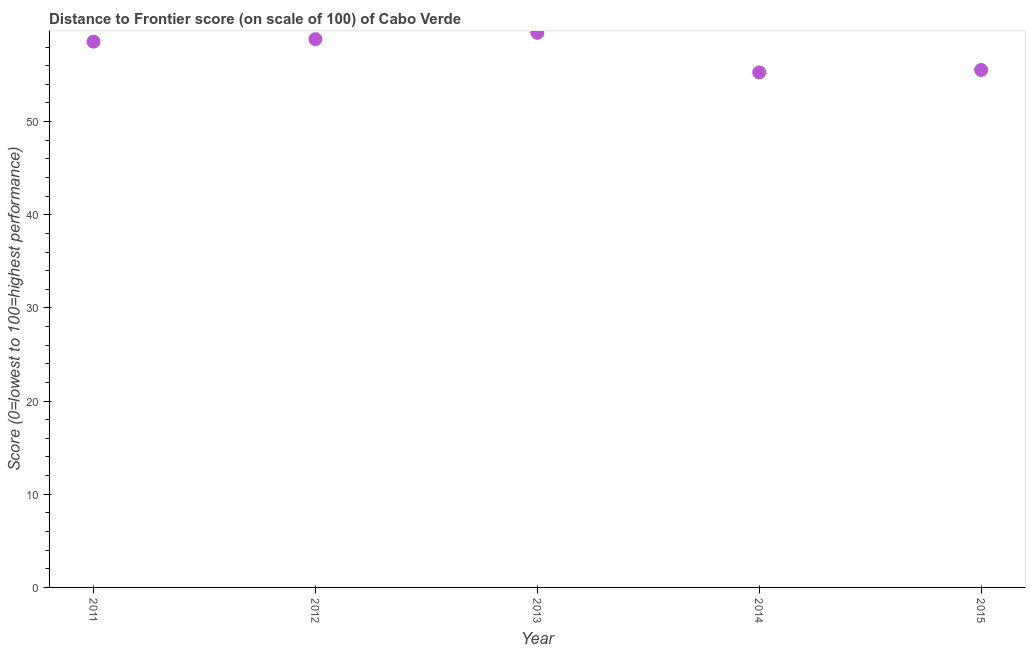What is the distance to frontier score in 2012?
Ensure brevity in your answer.  58.85. Across all years, what is the maximum distance to frontier score?
Offer a terse response. 59.53. Across all years, what is the minimum distance to frontier score?
Your response must be concise. 55.28. In which year was the distance to frontier score minimum?
Offer a terse response. 2014. What is the sum of the distance to frontier score?
Provide a short and direct response. 287.78. What is the difference between the distance to frontier score in 2012 and 2014?
Offer a very short reply. 3.57. What is the average distance to frontier score per year?
Your answer should be compact. 57.56. What is the median distance to frontier score?
Provide a short and direct response. 58.58. In how many years, is the distance to frontier score greater than 12 ?
Give a very brief answer. 5. Do a majority of the years between 2012 and 2011 (inclusive) have distance to frontier score greater than 14 ?
Make the answer very short. No. What is the ratio of the distance to frontier score in 2013 to that in 2015?
Keep it short and to the point. 1.07. Is the distance to frontier score in 2013 less than that in 2015?
Keep it short and to the point. No. What is the difference between the highest and the second highest distance to frontier score?
Offer a terse response. 0.68. What is the difference between the highest and the lowest distance to frontier score?
Provide a short and direct response. 4.25. Does the distance to frontier score monotonically increase over the years?
Keep it short and to the point. No. What is the difference between two consecutive major ticks on the Y-axis?
Make the answer very short. 10. Are the values on the major ticks of Y-axis written in scientific E-notation?
Give a very brief answer. No. Does the graph contain any zero values?
Make the answer very short. No. Does the graph contain grids?
Your answer should be compact. No. What is the title of the graph?
Your answer should be very brief. Distance to Frontier score (on scale of 100) of Cabo Verde. What is the label or title of the X-axis?
Offer a terse response. Year. What is the label or title of the Y-axis?
Your answer should be compact. Score (0=lowest to 100=highest performance). What is the Score (0=lowest to 100=highest performance) in 2011?
Ensure brevity in your answer.  58.58. What is the Score (0=lowest to 100=highest performance) in 2012?
Keep it short and to the point. 58.85. What is the Score (0=lowest to 100=highest performance) in 2013?
Give a very brief answer. 59.53. What is the Score (0=lowest to 100=highest performance) in 2014?
Offer a terse response. 55.28. What is the Score (0=lowest to 100=highest performance) in 2015?
Ensure brevity in your answer.  55.54. What is the difference between the Score (0=lowest to 100=highest performance) in 2011 and 2012?
Your answer should be very brief. -0.27. What is the difference between the Score (0=lowest to 100=highest performance) in 2011 and 2013?
Offer a terse response. -0.95. What is the difference between the Score (0=lowest to 100=highest performance) in 2011 and 2015?
Your response must be concise. 3.04. What is the difference between the Score (0=lowest to 100=highest performance) in 2012 and 2013?
Your response must be concise. -0.68. What is the difference between the Score (0=lowest to 100=highest performance) in 2012 and 2014?
Your answer should be compact. 3.57. What is the difference between the Score (0=lowest to 100=highest performance) in 2012 and 2015?
Your answer should be compact. 3.31. What is the difference between the Score (0=lowest to 100=highest performance) in 2013 and 2014?
Your response must be concise. 4.25. What is the difference between the Score (0=lowest to 100=highest performance) in 2013 and 2015?
Make the answer very short. 3.99. What is the difference between the Score (0=lowest to 100=highest performance) in 2014 and 2015?
Keep it short and to the point. -0.26. What is the ratio of the Score (0=lowest to 100=highest performance) in 2011 to that in 2012?
Ensure brevity in your answer.  0.99. What is the ratio of the Score (0=lowest to 100=highest performance) in 2011 to that in 2014?
Your response must be concise. 1.06. What is the ratio of the Score (0=lowest to 100=highest performance) in 2011 to that in 2015?
Your response must be concise. 1.05. What is the ratio of the Score (0=lowest to 100=highest performance) in 2012 to that in 2013?
Your answer should be very brief. 0.99. What is the ratio of the Score (0=lowest to 100=highest performance) in 2012 to that in 2014?
Your answer should be very brief. 1.06. What is the ratio of the Score (0=lowest to 100=highest performance) in 2012 to that in 2015?
Your answer should be very brief. 1.06. What is the ratio of the Score (0=lowest to 100=highest performance) in 2013 to that in 2014?
Keep it short and to the point. 1.08. What is the ratio of the Score (0=lowest to 100=highest performance) in 2013 to that in 2015?
Give a very brief answer. 1.07. 